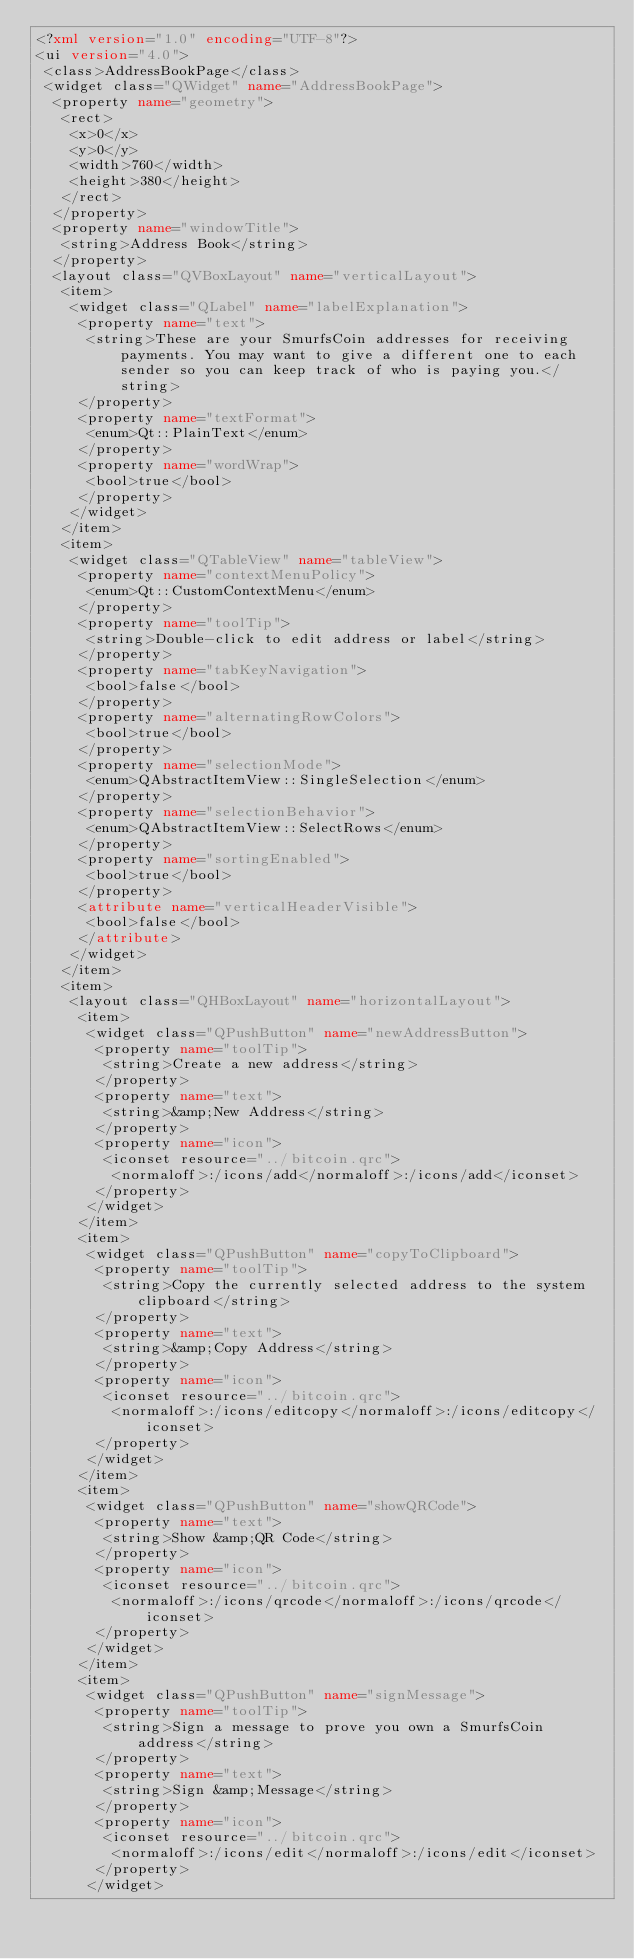<code> <loc_0><loc_0><loc_500><loc_500><_XML_><?xml version="1.0" encoding="UTF-8"?>
<ui version="4.0">
 <class>AddressBookPage</class>
 <widget class="QWidget" name="AddressBookPage">
  <property name="geometry">
   <rect>
    <x>0</x>
    <y>0</y>
    <width>760</width>
    <height>380</height>
   </rect>
  </property>
  <property name="windowTitle">
   <string>Address Book</string>
  </property>
  <layout class="QVBoxLayout" name="verticalLayout">
   <item>
    <widget class="QLabel" name="labelExplanation">
     <property name="text">
      <string>These are your SmurfsCoin addresses for receiving payments. You may want to give a different one to each sender so you can keep track of who is paying you.</string>
     </property>
     <property name="textFormat">
      <enum>Qt::PlainText</enum>
     </property>
     <property name="wordWrap">
      <bool>true</bool>
     </property>
    </widget>
   </item>
   <item>
    <widget class="QTableView" name="tableView">
     <property name="contextMenuPolicy">
      <enum>Qt::CustomContextMenu</enum>
     </property>
     <property name="toolTip">
      <string>Double-click to edit address or label</string>
     </property>
     <property name="tabKeyNavigation">
      <bool>false</bool>
     </property>
     <property name="alternatingRowColors">
      <bool>true</bool>
     </property>
     <property name="selectionMode">
      <enum>QAbstractItemView::SingleSelection</enum>
     </property>
     <property name="selectionBehavior">
      <enum>QAbstractItemView::SelectRows</enum>
     </property>
     <property name="sortingEnabled">
      <bool>true</bool>
     </property>
     <attribute name="verticalHeaderVisible">
      <bool>false</bool>
     </attribute>
    </widget>
   </item>
   <item>
    <layout class="QHBoxLayout" name="horizontalLayout">
     <item>
      <widget class="QPushButton" name="newAddressButton">
       <property name="toolTip">
        <string>Create a new address</string>
       </property>
       <property name="text">
        <string>&amp;New Address</string>
       </property>
       <property name="icon">
        <iconset resource="../bitcoin.qrc">
         <normaloff>:/icons/add</normaloff>:/icons/add</iconset>
       </property>
      </widget>
     </item>
     <item>
      <widget class="QPushButton" name="copyToClipboard">
       <property name="toolTip">
        <string>Copy the currently selected address to the system clipboard</string>
       </property>
       <property name="text">
        <string>&amp;Copy Address</string>
       </property>
       <property name="icon">
        <iconset resource="../bitcoin.qrc">
         <normaloff>:/icons/editcopy</normaloff>:/icons/editcopy</iconset>
       </property>
      </widget>
     </item>
     <item>
      <widget class="QPushButton" name="showQRCode">
       <property name="text">
        <string>Show &amp;QR Code</string>
       </property>
       <property name="icon">
        <iconset resource="../bitcoin.qrc">
         <normaloff>:/icons/qrcode</normaloff>:/icons/qrcode</iconset>
       </property>
      </widget>
     </item>
     <item>
      <widget class="QPushButton" name="signMessage">
       <property name="toolTip">
        <string>Sign a message to prove you own a SmurfsCoin address</string>
       </property>
       <property name="text">
        <string>Sign &amp;Message</string>
       </property>
       <property name="icon">
        <iconset resource="../bitcoin.qrc">
         <normaloff>:/icons/edit</normaloff>:/icons/edit</iconset>
       </property>
      </widget></code> 